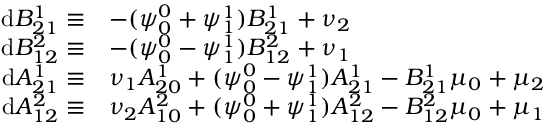Convert formula to latex. <formula><loc_0><loc_0><loc_500><loc_500>\begin{array} { r l } { d B _ { 2 1 } ^ { 1 } \equiv } & { - ( \psi _ { 0 } ^ { 0 } + \psi _ { 1 } ^ { 1 } ) B _ { 2 1 } ^ { 1 } + \nu _ { 2 } } \\ { d B _ { 1 2 } ^ { 2 } \equiv } & { - ( \psi _ { 0 } ^ { 0 } - \psi _ { 1 } ^ { 1 } ) B _ { 1 2 } ^ { 2 } + \nu _ { 1 } } \\ { d A _ { 2 1 } ^ { 1 } \equiv } & { \nu _ { 1 } A _ { 2 0 } ^ { 1 } + ( \psi _ { 0 } ^ { 0 } - \psi _ { 1 } ^ { 1 } ) A _ { 2 1 } ^ { 1 } - B _ { 2 1 } ^ { 1 } \mu _ { 0 } + \mu _ { 2 } } \\ { d A _ { 1 2 } ^ { 2 } \equiv } & { \nu _ { 2 } A _ { 1 0 } ^ { 2 } + ( \psi _ { 0 } ^ { 0 } + \psi _ { 1 } ^ { 1 } ) A _ { 1 2 } ^ { 2 } - B _ { 1 2 } ^ { 2 } \mu _ { 0 } + \mu _ { 1 } } \end{array}</formula> 